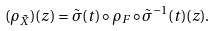<formula> <loc_0><loc_0><loc_500><loc_500>( \rho _ { \tilde { X } } ) ( z ) = \tilde { \sigma } ( t ) \circ \rho _ { F } \circ \tilde { \sigma } ^ { - 1 } ( t ) ( z ) .</formula> 